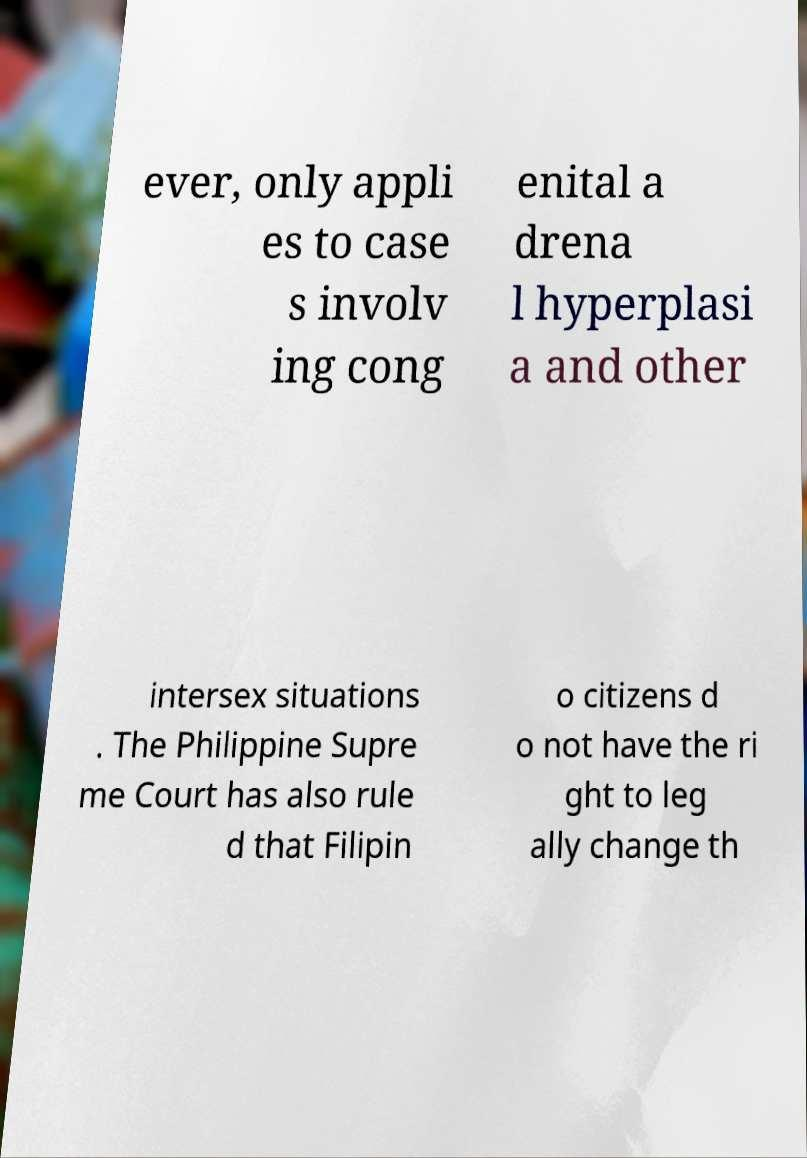Could you assist in decoding the text presented in this image and type it out clearly? ever, only appli es to case s involv ing cong enital a drena l hyperplasi a and other intersex situations . The Philippine Supre me Court has also rule d that Filipin o citizens d o not have the ri ght to leg ally change th 